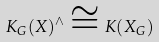Convert formula to latex. <formula><loc_0><loc_0><loc_500><loc_500>K _ { G } ( X ) ^ { \wedge } \cong K ( X _ { G } )</formula> 